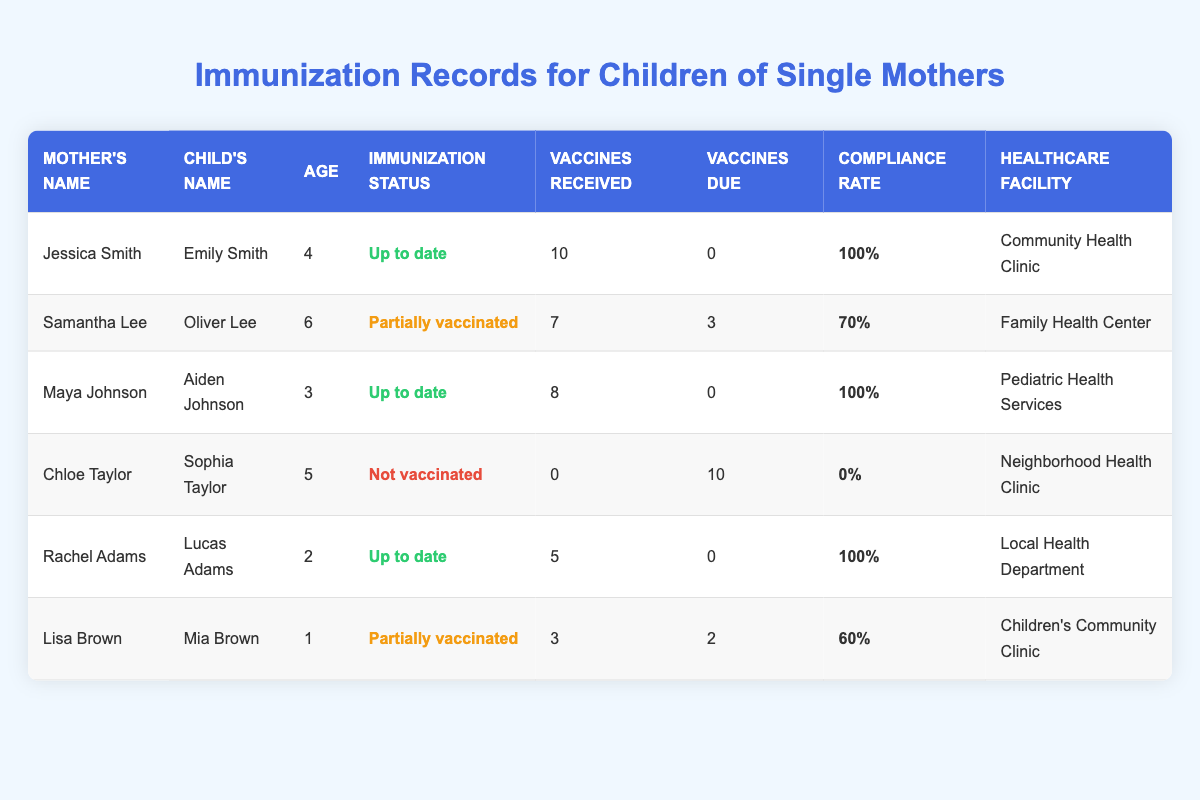What is the immunization status of Aiden Johnson? To find the immunization status of Aiden Johnson, we locate Maya Johnson in the table, who is listed as Aiden's mother. Aiden's immunization status is marked as "Up to date."
Answer: Up to date How many vaccines has Mia Brown received? Looking at the row for Mia Brown, the number of vaccines received is listed as 3.
Answer: 3 Which child has the highest compliance rate? We check the compliance rates listed in the table: Emily Smith, Aiden Johnson, and Lucas Adams all have compliance rates of 100%, which are the highest.
Answer: Emily Smith, Aiden Johnson, and Lucas Adams What age is Oliver Lee? In the table, Oliver Lee is listed under Samantha Lee, and his age is stated as 6.
Answer: 6 How many children are fully vaccinated (100% compliance)? We count the entries with a compliance rate of 100%. The children are Emily Smith, Aiden Johnson, and Lucas Adams, totaling 3 fully vaccinated children.
Answer: 3 Is Chloe Taylor's child vaccinated? Chloe Taylor's child, Sophia Taylor, is noted to be "Not vaccinated" in the table.
Answer: No What is the average number of vaccines received by children who are partially vaccinated? There are two partially vaccinated children, Oliver Lee (7 vaccines) and Mia Brown (3 vaccines). Adding them gives a total of 10 vaccines. We divide by 2 (the number of children) to find the average: 10 / 2 = 5.
Answer: 5 How many total vaccines are due for all children in the table? We sum the vaccines due for each child: 0 + 3 + 0 + 10 + 0 + 2 = 15 total vaccines due.
Answer: 15 Which healthcare facility has the most vaccinated children? We see that the facilities with fully vaccinated children (100% compliance) are Community Health Clinic, Pediatric Health Services, and Local Health Department. Each has one child fully vaccinated. However, Neighborhood Health Clinic has one child who is not vaccinated. Thus, none has more than one vaccinated child; all are equal.
Answer: All are equal with 1 fully vaccinated child each What percentage of children are not vaccinated? Only one child (Sophia Taylor) is not vaccinated out of six total children. Calculating this gives: (1 / 6) * 100 = 16.67%.
Answer: Approximately 16.67% 